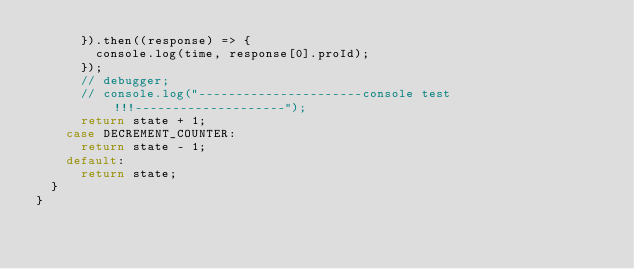Convert code to text. <code><loc_0><loc_0><loc_500><loc_500><_JavaScript_>      }).then((response) => {
        console.log(time, response[0].proId);
      });
      // debugger;
      // console.log("----------------------console test!!!--------------------");
      return state + 1;
    case DECREMENT_COUNTER:
      return state - 1;
    default:
      return state;
  }
}
</code> 